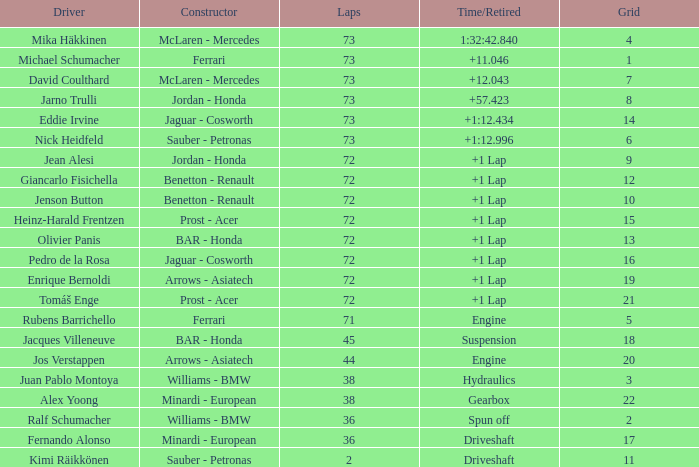Who is the constructor when the laps is more than 72 and the driver is eddie irvine? Jaguar - Cosworth. 